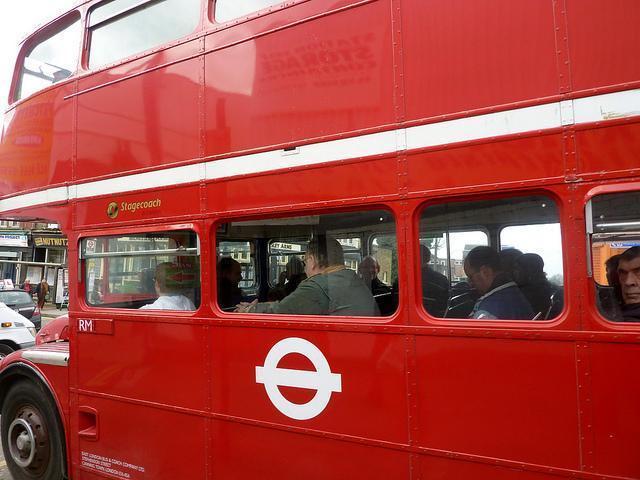How many people are there?
Give a very brief answer. 2. How many toilets are here?
Give a very brief answer. 0. 